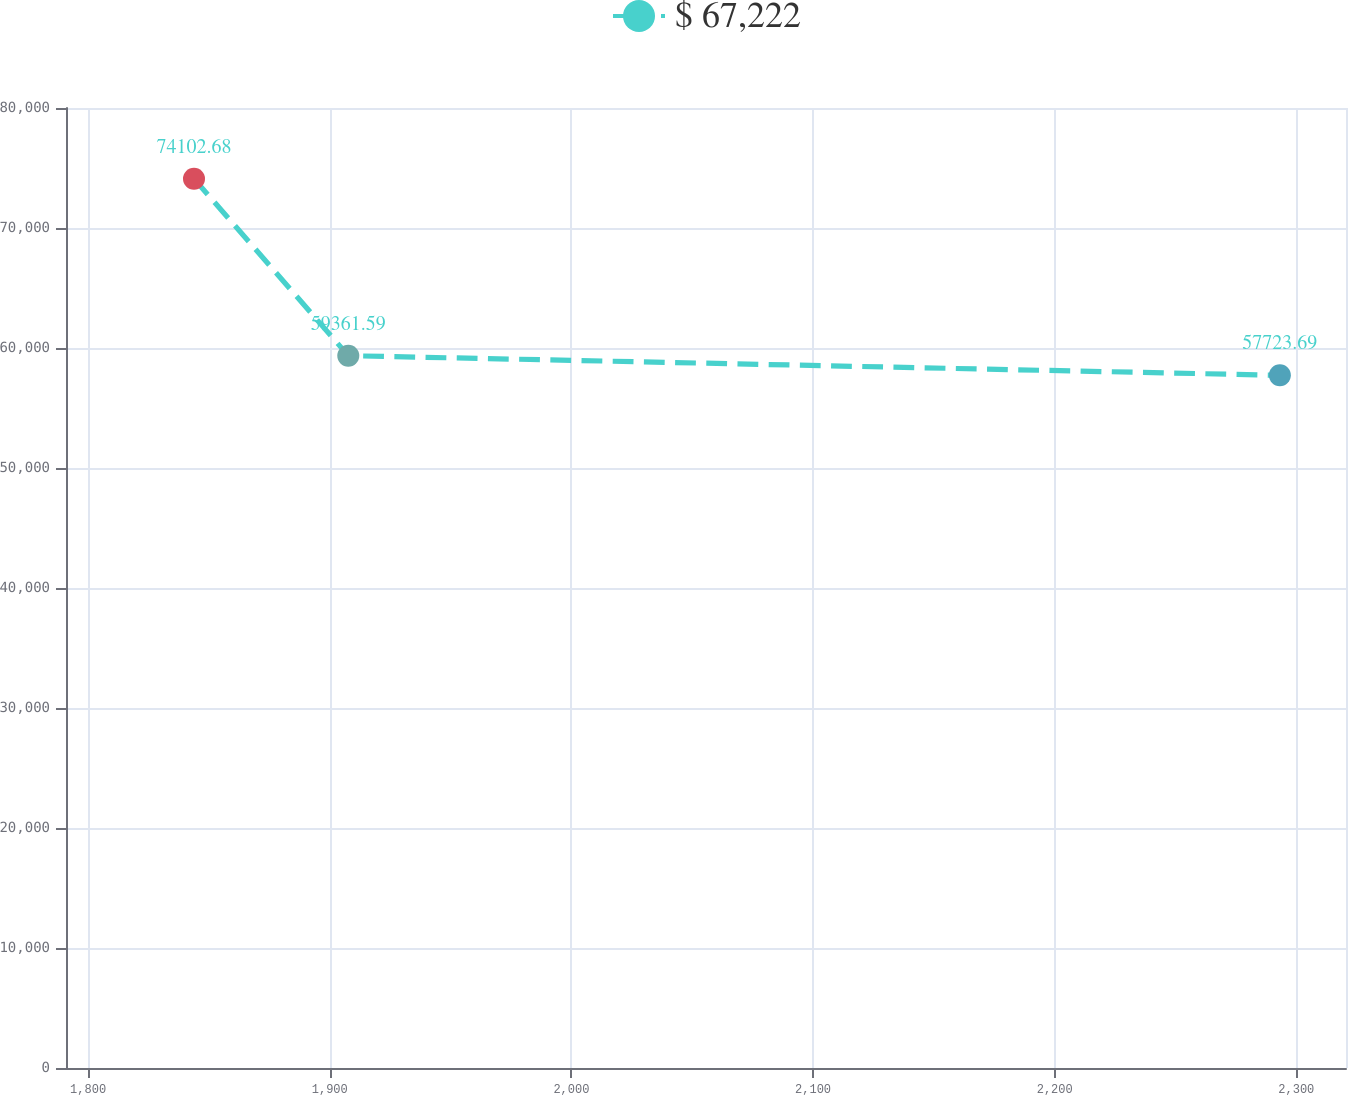<chart> <loc_0><loc_0><loc_500><loc_500><line_chart><ecel><fcel>$ 67,222<nl><fcel>1843.82<fcel>74102.7<nl><fcel>1907.67<fcel>59361.6<nl><fcel>2293.19<fcel>57723.7<nl><fcel>2373.53<fcel>60999.5<nl></chart> 